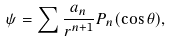Convert formula to latex. <formula><loc_0><loc_0><loc_500><loc_500>\psi = \sum \frac { a _ { n } } { r ^ { n + 1 } } P _ { n } ( \cos \theta ) ,</formula> 